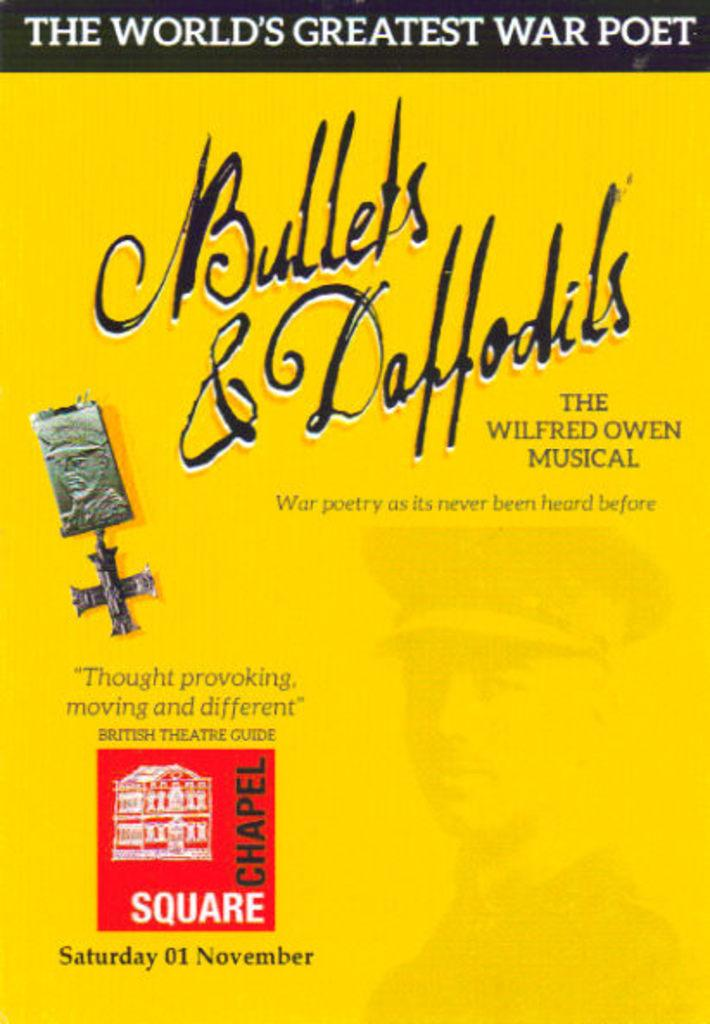What can be seen on the poster in the image? There is a poster in the image, and it has text on it. Can you describe the text on the poster? Unfortunately, the specific text on the poster cannot be determined from the provided facts. However, we know that there is text present on the poster. Is there any grass visible in the image? There is no mention of grass in the provided facts, so we cannot determine if it is present in the image. Can you describe the trouble the poster is causing in the image? There is no mention of any trouble or issue related to the poster in the provided facts, so we cannot determine if it is causing any problems. 